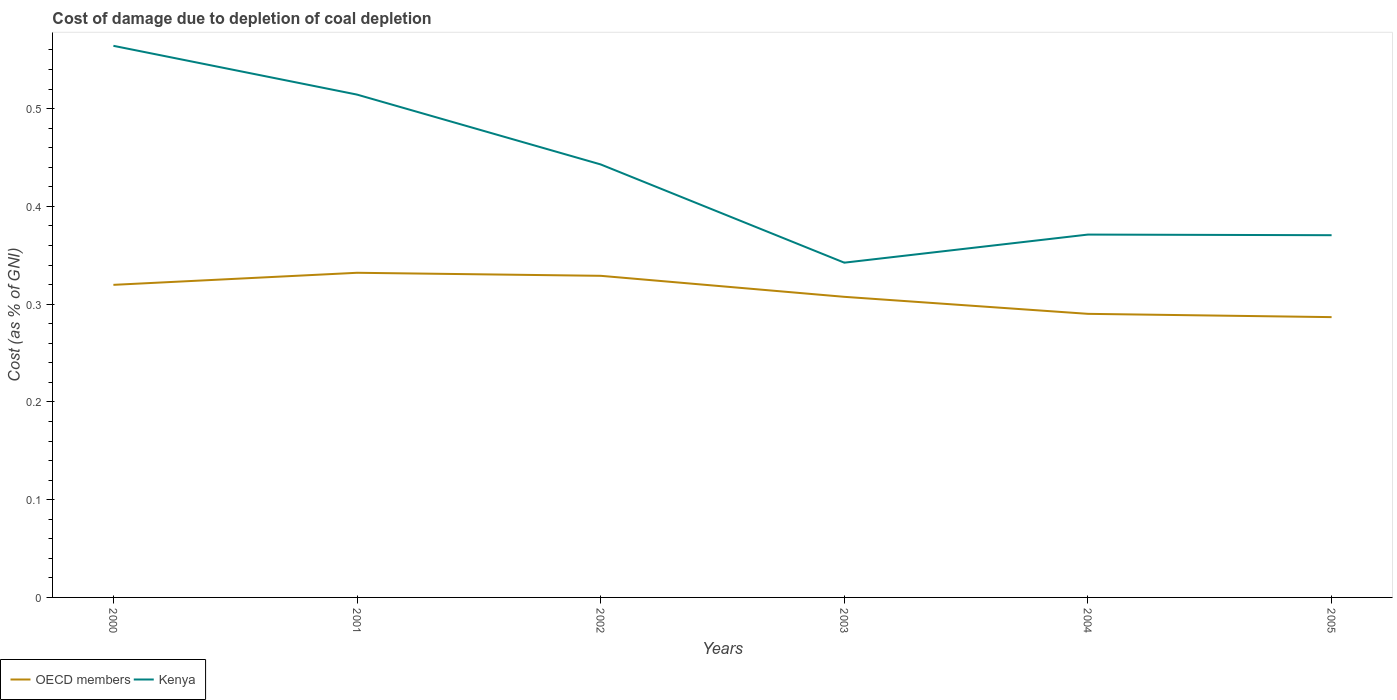Does the line corresponding to OECD members intersect with the line corresponding to Kenya?
Provide a succinct answer. No. Is the number of lines equal to the number of legend labels?
Ensure brevity in your answer.  Yes. Across all years, what is the maximum cost of damage caused due to coal depletion in Kenya?
Provide a short and direct response. 0.34. What is the total cost of damage caused due to coal depletion in Kenya in the graph?
Your answer should be very brief. 0.17. What is the difference between the highest and the second highest cost of damage caused due to coal depletion in Kenya?
Give a very brief answer. 0.22. What is the difference between the highest and the lowest cost of damage caused due to coal depletion in OECD members?
Ensure brevity in your answer.  3. How many lines are there?
Give a very brief answer. 2. How many years are there in the graph?
Keep it short and to the point. 6. What is the difference between two consecutive major ticks on the Y-axis?
Ensure brevity in your answer.  0.1. Does the graph contain grids?
Your answer should be compact. No. How are the legend labels stacked?
Make the answer very short. Horizontal. What is the title of the graph?
Offer a terse response. Cost of damage due to depletion of coal depletion. Does "Belgium" appear as one of the legend labels in the graph?
Offer a very short reply. No. What is the label or title of the X-axis?
Ensure brevity in your answer.  Years. What is the label or title of the Y-axis?
Your answer should be compact. Cost (as % of GNI). What is the Cost (as % of GNI) in OECD members in 2000?
Give a very brief answer. 0.32. What is the Cost (as % of GNI) of Kenya in 2000?
Provide a short and direct response. 0.56. What is the Cost (as % of GNI) of OECD members in 2001?
Provide a short and direct response. 0.33. What is the Cost (as % of GNI) of Kenya in 2001?
Provide a succinct answer. 0.51. What is the Cost (as % of GNI) of OECD members in 2002?
Give a very brief answer. 0.33. What is the Cost (as % of GNI) in Kenya in 2002?
Your answer should be compact. 0.44. What is the Cost (as % of GNI) in OECD members in 2003?
Your answer should be compact. 0.31. What is the Cost (as % of GNI) in Kenya in 2003?
Give a very brief answer. 0.34. What is the Cost (as % of GNI) in OECD members in 2004?
Offer a very short reply. 0.29. What is the Cost (as % of GNI) of Kenya in 2004?
Give a very brief answer. 0.37. What is the Cost (as % of GNI) of OECD members in 2005?
Give a very brief answer. 0.29. What is the Cost (as % of GNI) of Kenya in 2005?
Keep it short and to the point. 0.37. Across all years, what is the maximum Cost (as % of GNI) in OECD members?
Ensure brevity in your answer.  0.33. Across all years, what is the maximum Cost (as % of GNI) in Kenya?
Offer a very short reply. 0.56. Across all years, what is the minimum Cost (as % of GNI) in OECD members?
Offer a very short reply. 0.29. Across all years, what is the minimum Cost (as % of GNI) in Kenya?
Keep it short and to the point. 0.34. What is the total Cost (as % of GNI) of OECD members in the graph?
Your answer should be compact. 1.86. What is the total Cost (as % of GNI) in Kenya in the graph?
Offer a very short reply. 2.61. What is the difference between the Cost (as % of GNI) in OECD members in 2000 and that in 2001?
Offer a very short reply. -0.01. What is the difference between the Cost (as % of GNI) in Kenya in 2000 and that in 2001?
Make the answer very short. 0.05. What is the difference between the Cost (as % of GNI) in OECD members in 2000 and that in 2002?
Your response must be concise. -0.01. What is the difference between the Cost (as % of GNI) of Kenya in 2000 and that in 2002?
Give a very brief answer. 0.12. What is the difference between the Cost (as % of GNI) in OECD members in 2000 and that in 2003?
Your answer should be very brief. 0.01. What is the difference between the Cost (as % of GNI) in Kenya in 2000 and that in 2003?
Offer a terse response. 0.22. What is the difference between the Cost (as % of GNI) in OECD members in 2000 and that in 2004?
Ensure brevity in your answer.  0.03. What is the difference between the Cost (as % of GNI) in Kenya in 2000 and that in 2004?
Offer a very short reply. 0.19. What is the difference between the Cost (as % of GNI) of OECD members in 2000 and that in 2005?
Ensure brevity in your answer.  0.03. What is the difference between the Cost (as % of GNI) of Kenya in 2000 and that in 2005?
Keep it short and to the point. 0.19. What is the difference between the Cost (as % of GNI) of OECD members in 2001 and that in 2002?
Give a very brief answer. 0. What is the difference between the Cost (as % of GNI) in Kenya in 2001 and that in 2002?
Provide a succinct answer. 0.07. What is the difference between the Cost (as % of GNI) in OECD members in 2001 and that in 2003?
Your answer should be compact. 0.02. What is the difference between the Cost (as % of GNI) of Kenya in 2001 and that in 2003?
Offer a very short reply. 0.17. What is the difference between the Cost (as % of GNI) of OECD members in 2001 and that in 2004?
Make the answer very short. 0.04. What is the difference between the Cost (as % of GNI) of Kenya in 2001 and that in 2004?
Ensure brevity in your answer.  0.14. What is the difference between the Cost (as % of GNI) in OECD members in 2001 and that in 2005?
Provide a short and direct response. 0.05. What is the difference between the Cost (as % of GNI) of Kenya in 2001 and that in 2005?
Your response must be concise. 0.14. What is the difference between the Cost (as % of GNI) of OECD members in 2002 and that in 2003?
Give a very brief answer. 0.02. What is the difference between the Cost (as % of GNI) of Kenya in 2002 and that in 2003?
Your answer should be compact. 0.1. What is the difference between the Cost (as % of GNI) in OECD members in 2002 and that in 2004?
Provide a succinct answer. 0.04. What is the difference between the Cost (as % of GNI) of Kenya in 2002 and that in 2004?
Your answer should be compact. 0.07. What is the difference between the Cost (as % of GNI) of OECD members in 2002 and that in 2005?
Your answer should be very brief. 0.04. What is the difference between the Cost (as % of GNI) of Kenya in 2002 and that in 2005?
Provide a succinct answer. 0.07. What is the difference between the Cost (as % of GNI) in OECD members in 2003 and that in 2004?
Your answer should be very brief. 0.02. What is the difference between the Cost (as % of GNI) in Kenya in 2003 and that in 2004?
Your answer should be compact. -0.03. What is the difference between the Cost (as % of GNI) in OECD members in 2003 and that in 2005?
Keep it short and to the point. 0.02. What is the difference between the Cost (as % of GNI) of Kenya in 2003 and that in 2005?
Offer a very short reply. -0.03. What is the difference between the Cost (as % of GNI) of OECD members in 2004 and that in 2005?
Offer a very short reply. 0. What is the difference between the Cost (as % of GNI) of Kenya in 2004 and that in 2005?
Provide a succinct answer. 0. What is the difference between the Cost (as % of GNI) of OECD members in 2000 and the Cost (as % of GNI) of Kenya in 2001?
Give a very brief answer. -0.19. What is the difference between the Cost (as % of GNI) of OECD members in 2000 and the Cost (as % of GNI) of Kenya in 2002?
Provide a succinct answer. -0.12. What is the difference between the Cost (as % of GNI) in OECD members in 2000 and the Cost (as % of GNI) in Kenya in 2003?
Offer a terse response. -0.02. What is the difference between the Cost (as % of GNI) in OECD members in 2000 and the Cost (as % of GNI) in Kenya in 2004?
Ensure brevity in your answer.  -0.05. What is the difference between the Cost (as % of GNI) in OECD members in 2000 and the Cost (as % of GNI) in Kenya in 2005?
Make the answer very short. -0.05. What is the difference between the Cost (as % of GNI) in OECD members in 2001 and the Cost (as % of GNI) in Kenya in 2002?
Your response must be concise. -0.11. What is the difference between the Cost (as % of GNI) of OECD members in 2001 and the Cost (as % of GNI) of Kenya in 2003?
Provide a succinct answer. -0.01. What is the difference between the Cost (as % of GNI) of OECD members in 2001 and the Cost (as % of GNI) of Kenya in 2004?
Make the answer very short. -0.04. What is the difference between the Cost (as % of GNI) in OECD members in 2001 and the Cost (as % of GNI) in Kenya in 2005?
Your answer should be compact. -0.04. What is the difference between the Cost (as % of GNI) of OECD members in 2002 and the Cost (as % of GNI) of Kenya in 2003?
Your response must be concise. -0.01. What is the difference between the Cost (as % of GNI) in OECD members in 2002 and the Cost (as % of GNI) in Kenya in 2004?
Your answer should be very brief. -0.04. What is the difference between the Cost (as % of GNI) in OECD members in 2002 and the Cost (as % of GNI) in Kenya in 2005?
Give a very brief answer. -0.04. What is the difference between the Cost (as % of GNI) of OECD members in 2003 and the Cost (as % of GNI) of Kenya in 2004?
Give a very brief answer. -0.06. What is the difference between the Cost (as % of GNI) in OECD members in 2003 and the Cost (as % of GNI) in Kenya in 2005?
Keep it short and to the point. -0.06. What is the difference between the Cost (as % of GNI) of OECD members in 2004 and the Cost (as % of GNI) of Kenya in 2005?
Your response must be concise. -0.08. What is the average Cost (as % of GNI) of OECD members per year?
Ensure brevity in your answer.  0.31. What is the average Cost (as % of GNI) in Kenya per year?
Offer a very short reply. 0.43. In the year 2000, what is the difference between the Cost (as % of GNI) of OECD members and Cost (as % of GNI) of Kenya?
Provide a succinct answer. -0.24. In the year 2001, what is the difference between the Cost (as % of GNI) in OECD members and Cost (as % of GNI) in Kenya?
Provide a short and direct response. -0.18. In the year 2002, what is the difference between the Cost (as % of GNI) of OECD members and Cost (as % of GNI) of Kenya?
Provide a succinct answer. -0.11. In the year 2003, what is the difference between the Cost (as % of GNI) of OECD members and Cost (as % of GNI) of Kenya?
Provide a short and direct response. -0.03. In the year 2004, what is the difference between the Cost (as % of GNI) of OECD members and Cost (as % of GNI) of Kenya?
Make the answer very short. -0.08. In the year 2005, what is the difference between the Cost (as % of GNI) of OECD members and Cost (as % of GNI) of Kenya?
Your answer should be compact. -0.08. What is the ratio of the Cost (as % of GNI) in OECD members in 2000 to that in 2001?
Provide a succinct answer. 0.96. What is the ratio of the Cost (as % of GNI) in Kenya in 2000 to that in 2001?
Your response must be concise. 1.1. What is the ratio of the Cost (as % of GNI) of OECD members in 2000 to that in 2002?
Provide a short and direct response. 0.97. What is the ratio of the Cost (as % of GNI) in Kenya in 2000 to that in 2002?
Make the answer very short. 1.27. What is the ratio of the Cost (as % of GNI) of OECD members in 2000 to that in 2003?
Keep it short and to the point. 1.04. What is the ratio of the Cost (as % of GNI) in Kenya in 2000 to that in 2003?
Your answer should be very brief. 1.65. What is the ratio of the Cost (as % of GNI) in OECD members in 2000 to that in 2004?
Your answer should be compact. 1.1. What is the ratio of the Cost (as % of GNI) in Kenya in 2000 to that in 2004?
Offer a terse response. 1.52. What is the ratio of the Cost (as % of GNI) of OECD members in 2000 to that in 2005?
Your response must be concise. 1.12. What is the ratio of the Cost (as % of GNI) in Kenya in 2000 to that in 2005?
Make the answer very short. 1.52. What is the ratio of the Cost (as % of GNI) in OECD members in 2001 to that in 2002?
Give a very brief answer. 1.01. What is the ratio of the Cost (as % of GNI) of Kenya in 2001 to that in 2002?
Offer a terse response. 1.16. What is the ratio of the Cost (as % of GNI) of OECD members in 2001 to that in 2003?
Keep it short and to the point. 1.08. What is the ratio of the Cost (as % of GNI) of Kenya in 2001 to that in 2003?
Make the answer very short. 1.5. What is the ratio of the Cost (as % of GNI) of OECD members in 2001 to that in 2004?
Give a very brief answer. 1.14. What is the ratio of the Cost (as % of GNI) in Kenya in 2001 to that in 2004?
Offer a terse response. 1.39. What is the ratio of the Cost (as % of GNI) of OECD members in 2001 to that in 2005?
Ensure brevity in your answer.  1.16. What is the ratio of the Cost (as % of GNI) of Kenya in 2001 to that in 2005?
Provide a short and direct response. 1.39. What is the ratio of the Cost (as % of GNI) of OECD members in 2002 to that in 2003?
Offer a very short reply. 1.07. What is the ratio of the Cost (as % of GNI) of Kenya in 2002 to that in 2003?
Offer a terse response. 1.29. What is the ratio of the Cost (as % of GNI) of OECD members in 2002 to that in 2004?
Offer a terse response. 1.13. What is the ratio of the Cost (as % of GNI) of Kenya in 2002 to that in 2004?
Provide a short and direct response. 1.19. What is the ratio of the Cost (as % of GNI) in OECD members in 2002 to that in 2005?
Keep it short and to the point. 1.15. What is the ratio of the Cost (as % of GNI) in Kenya in 2002 to that in 2005?
Offer a terse response. 1.2. What is the ratio of the Cost (as % of GNI) in OECD members in 2003 to that in 2004?
Your answer should be compact. 1.06. What is the ratio of the Cost (as % of GNI) in Kenya in 2003 to that in 2004?
Give a very brief answer. 0.92. What is the ratio of the Cost (as % of GNI) of OECD members in 2003 to that in 2005?
Your answer should be compact. 1.07. What is the ratio of the Cost (as % of GNI) in Kenya in 2003 to that in 2005?
Provide a short and direct response. 0.92. What is the ratio of the Cost (as % of GNI) in OECD members in 2004 to that in 2005?
Provide a succinct answer. 1.01. What is the difference between the highest and the second highest Cost (as % of GNI) of OECD members?
Make the answer very short. 0. What is the difference between the highest and the second highest Cost (as % of GNI) of Kenya?
Provide a short and direct response. 0.05. What is the difference between the highest and the lowest Cost (as % of GNI) of OECD members?
Keep it short and to the point. 0.05. What is the difference between the highest and the lowest Cost (as % of GNI) in Kenya?
Provide a succinct answer. 0.22. 